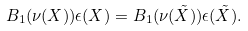<formula> <loc_0><loc_0><loc_500><loc_500>B _ { 1 } ( \nu ( X ) ) \epsilon ( X ) = B _ { 1 } ( \nu ( \tilde { X } ) ) \epsilon ( \tilde { X } ) .</formula> 